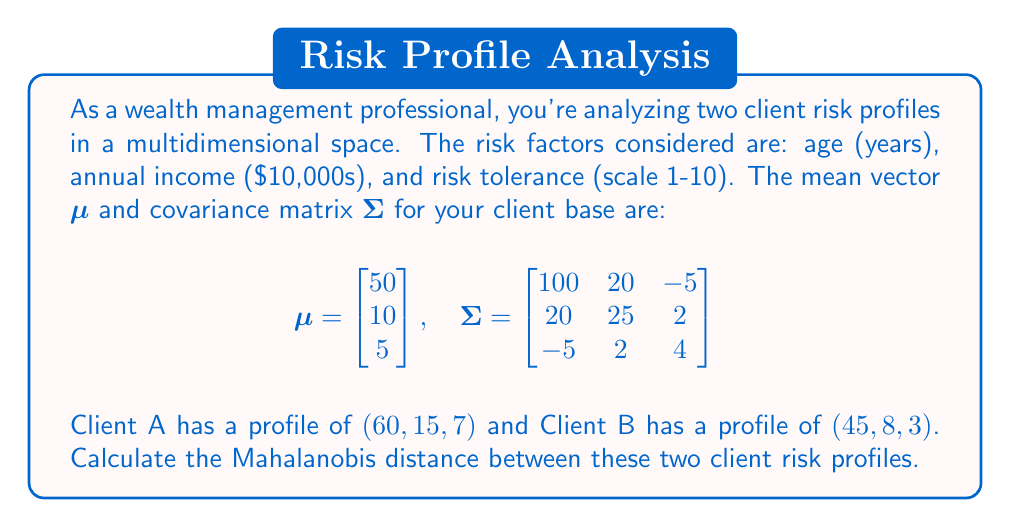Help me with this question. To calculate the Mahalanobis distance between two points in a multidimensional space, we'll follow these steps:

1) The Mahalanobis distance is given by the formula:
   $$d = \sqrt{(x_1 - x_2)^T \Sigma^{-1} (x_1 - x_2)}$$
   where $x_1$ and $x_2$ are the vectors representing the two points, and $\Sigma^{-1}$ is the inverse of the covariance matrix.

2) First, let's calculate $(x_1 - x_2)$:
   $$x_1 - x_2 = \begin{bmatrix} 60 \\ 15 \\ 7 \end{bmatrix} - \begin{bmatrix} 45 \\ 8 \\ 3 \end{bmatrix} = \begin{bmatrix} 15 \\ 7 \\ 4 \end{bmatrix}$$

3) Next, we need to find $\Sigma^{-1}$. Using a matrix calculator, we get:
   $$\Sigma^{-1} = \begin{bmatrix} 
   0.0106 & -0.0084 & 0.0135 \\
   -0.0084 & 0.0431 & -0.0068 \\
   0.0135 & -0.0068 & 0.2613
   \end{bmatrix}$$

4) Now, we calculate $(x_1 - x_2)^T \Sigma^{-1} (x_1 - x_2)$:
   $$\begin{bmatrix} 15 & 7 & 4 \end{bmatrix} 
   \begin{bmatrix} 
   0.0106 & -0.0084 & 0.0135 \\
   -0.0084 & 0.0431 & -0.0068 \\
   0.0135 & -0.0068 & 0.2613
   \end{bmatrix}
   \begin{bmatrix} 15 \\ 7 \\ 4 \end{bmatrix}$$

5) Performing this matrix multiplication:
   $$(0.1590 + (-0.0588) + 0.0540) \cdot 15 + 
   ((-0.1260) + 0.3017 + (-0.0272)) \cdot 7 + 
   (0.2025 + (-0.0476) + 1.0452) \cdot 4$$
   
   $$= 2.3130 + 1.2395 + 4.8004 = 8.3529$$

6) Finally, we take the square root:
   $$d = \sqrt{8.3529} = 2.8901$$

Therefore, the Mahalanobis distance between the two client risk profiles is approximately 2.8901.
Answer: 2.8901 